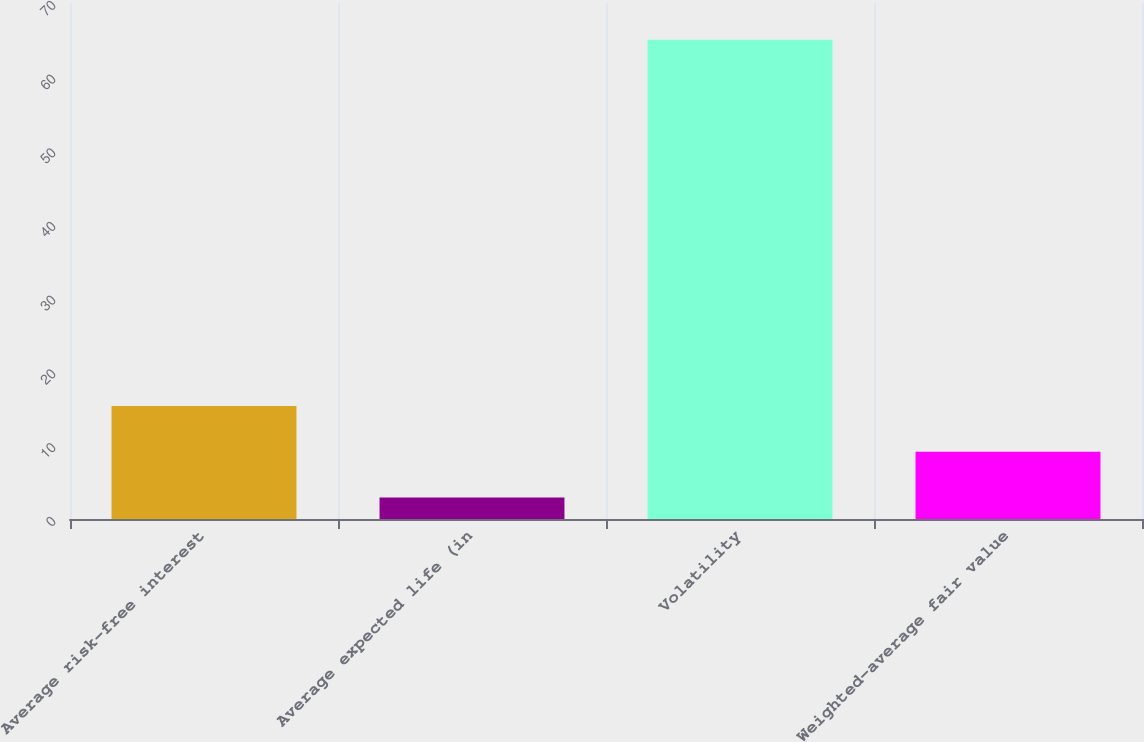<chart> <loc_0><loc_0><loc_500><loc_500><bar_chart><fcel>Average risk-free interest<fcel>Average expected life (in<fcel>Volatility<fcel>Weighted-average fair value<nl><fcel>15.33<fcel>2.91<fcel>65<fcel>9.12<nl></chart> 